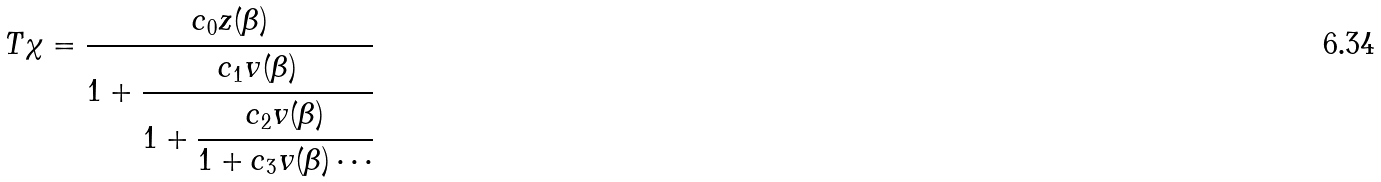Convert formula to latex. <formula><loc_0><loc_0><loc_500><loc_500>T \chi = \cfrac { c _ { 0 } z ( \beta ) } { 1 + \cfrac { c _ { 1 } v ( \beta ) } { 1 + \cfrac { c _ { 2 } v ( \beta ) } { 1 + c _ { 3 } v ( \beta ) \cdots } } }</formula> 